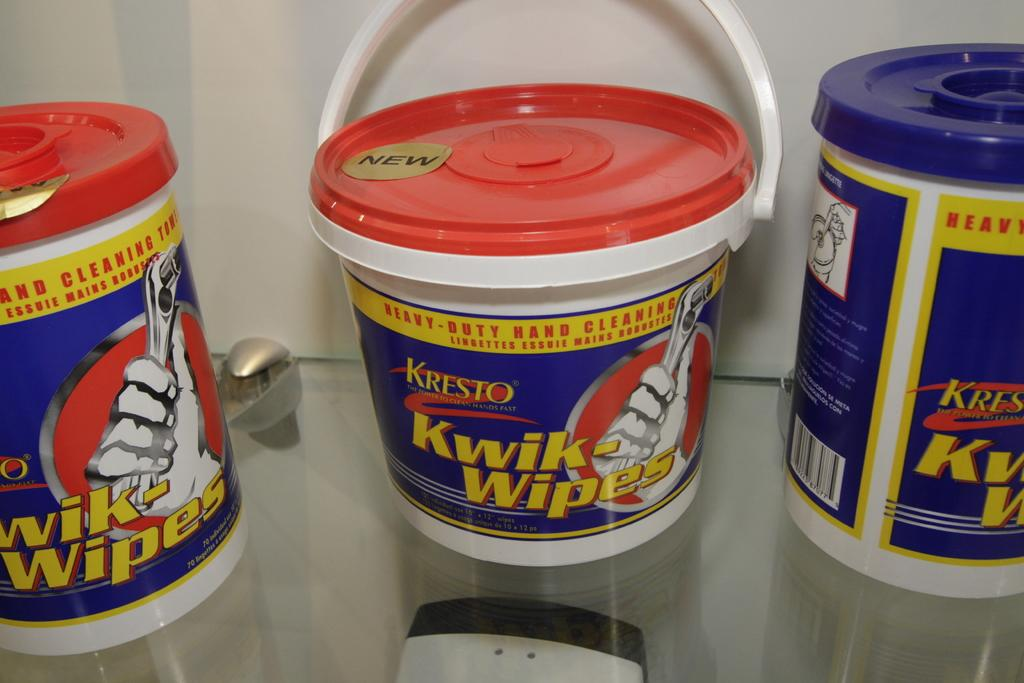<image>
Share a concise interpretation of the image provided. Three buckets that say Kwik-Wipes are on a glass shelf. 